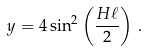Convert formula to latex. <formula><loc_0><loc_0><loc_500><loc_500>y = 4 \sin ^ { 2 } \left ( \frac { H \ell } { 2 } \right ) \, .</formula> 